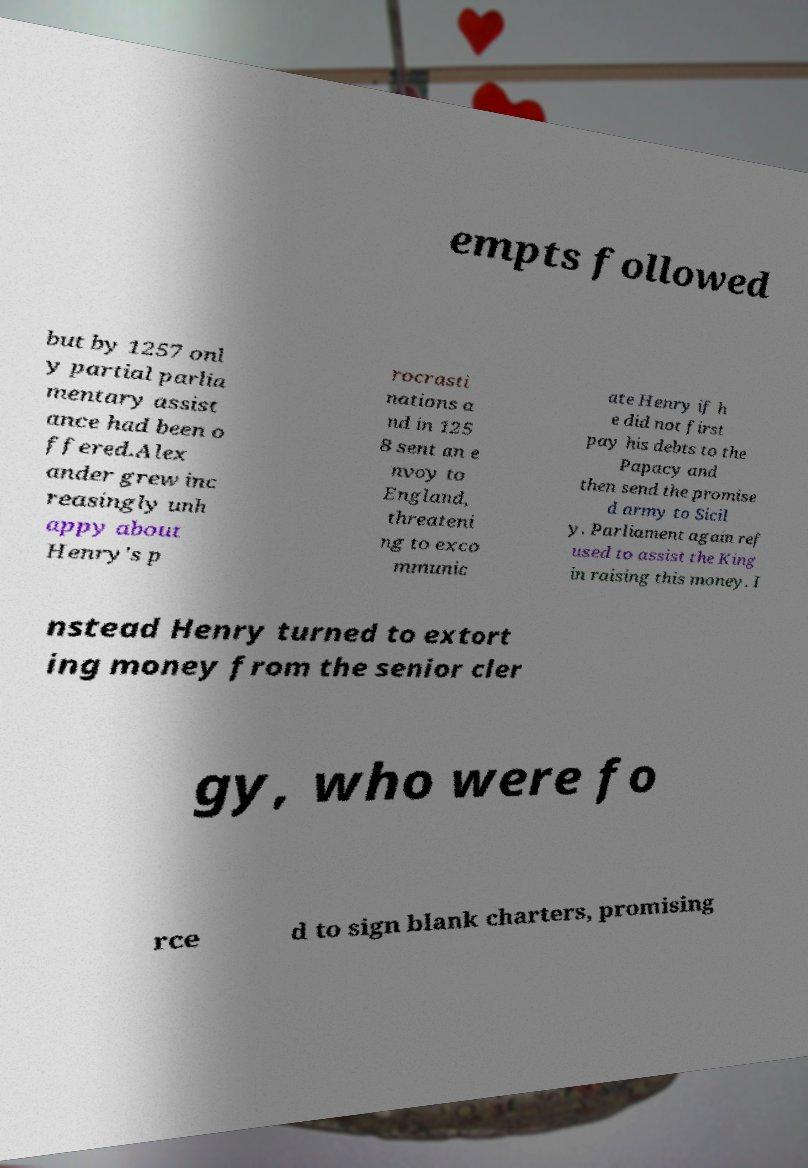Can you read and provide the text displayed in the image?This photo seems to have some interesting text. Can you extract and type it out for me? empts followed but by 1257 onl y partial parlia mentary assist ance had been o ffered.Alex ander grew inc reasingly unh appy about Henry's p rocrasti nations a nd in 125 8 sent an e nvoy to England, threateni ng to exco mmunic ate Henry if h e did not first pay his debts to the Papacy and then send the promise d army to Sicil y. Parliament again ref used to assist the King in raising this money. I nstead Henry turned to extort ing money from the senior cler gy, who were fo rce d to sign blank charters, promising 